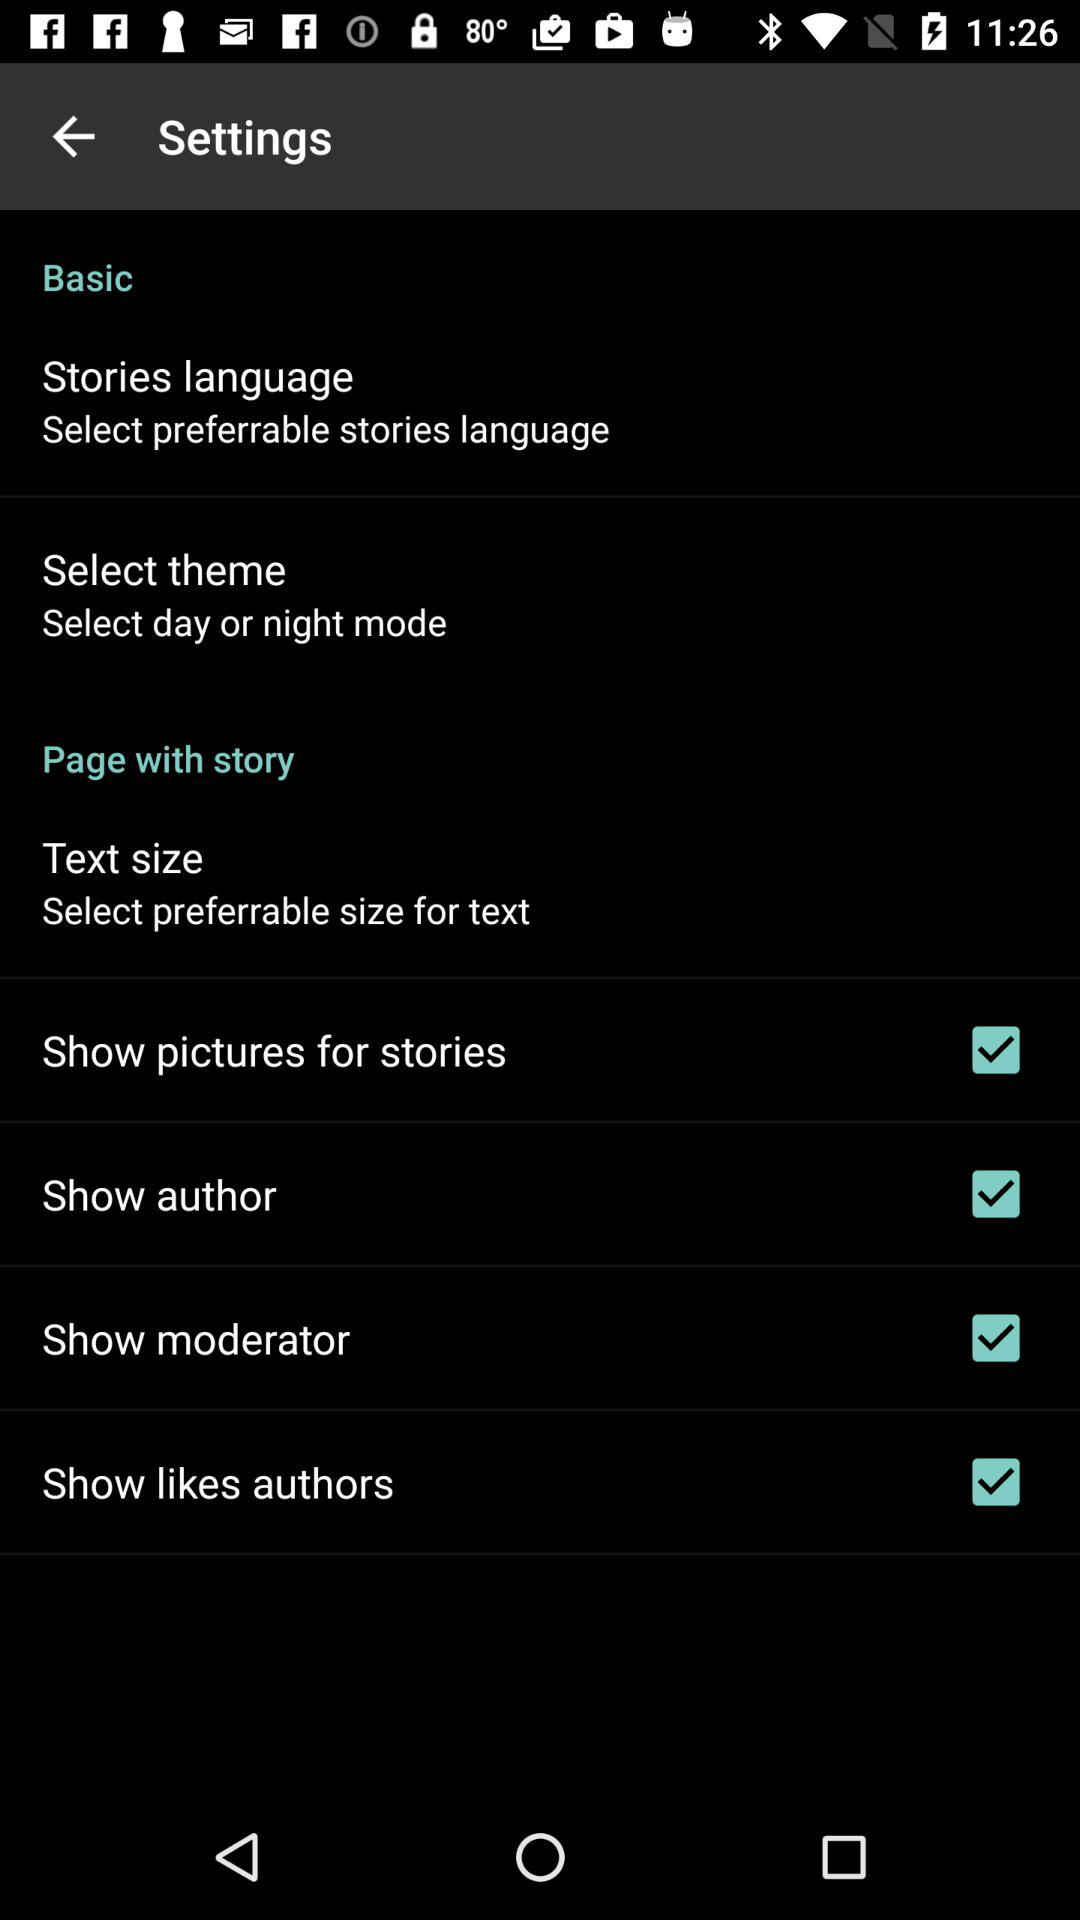What is the status of the "Show pictures for stories"? The status is "on". 